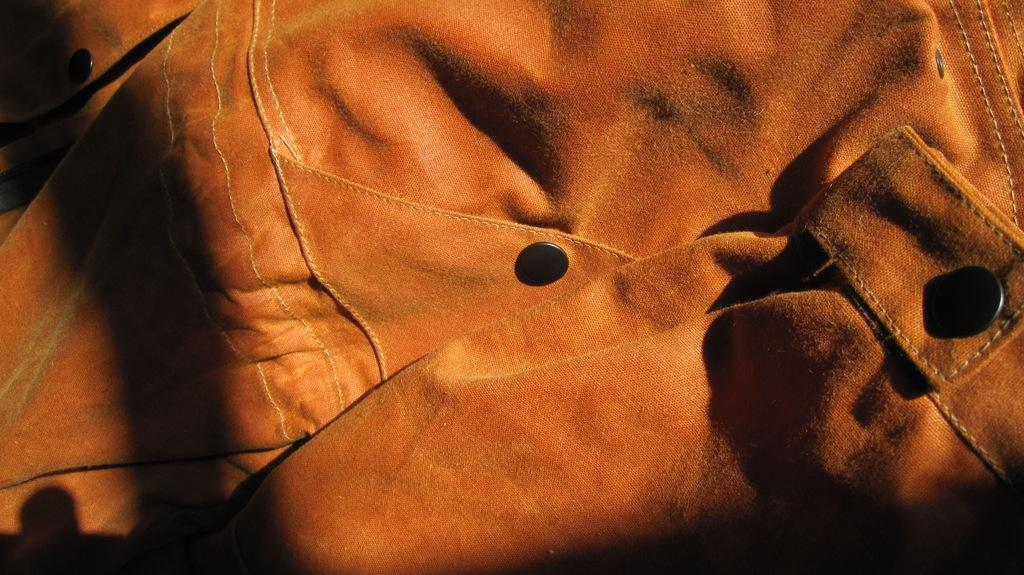What type of material is present in the image? There is a cloth in the image. What other objects can be seen in the image? There are buttons in the image. Where is the gun located in the image? There is no gun present in the image. What color is the lipstick on the cloth in the image? There is no lipstick or lip present in the image. 